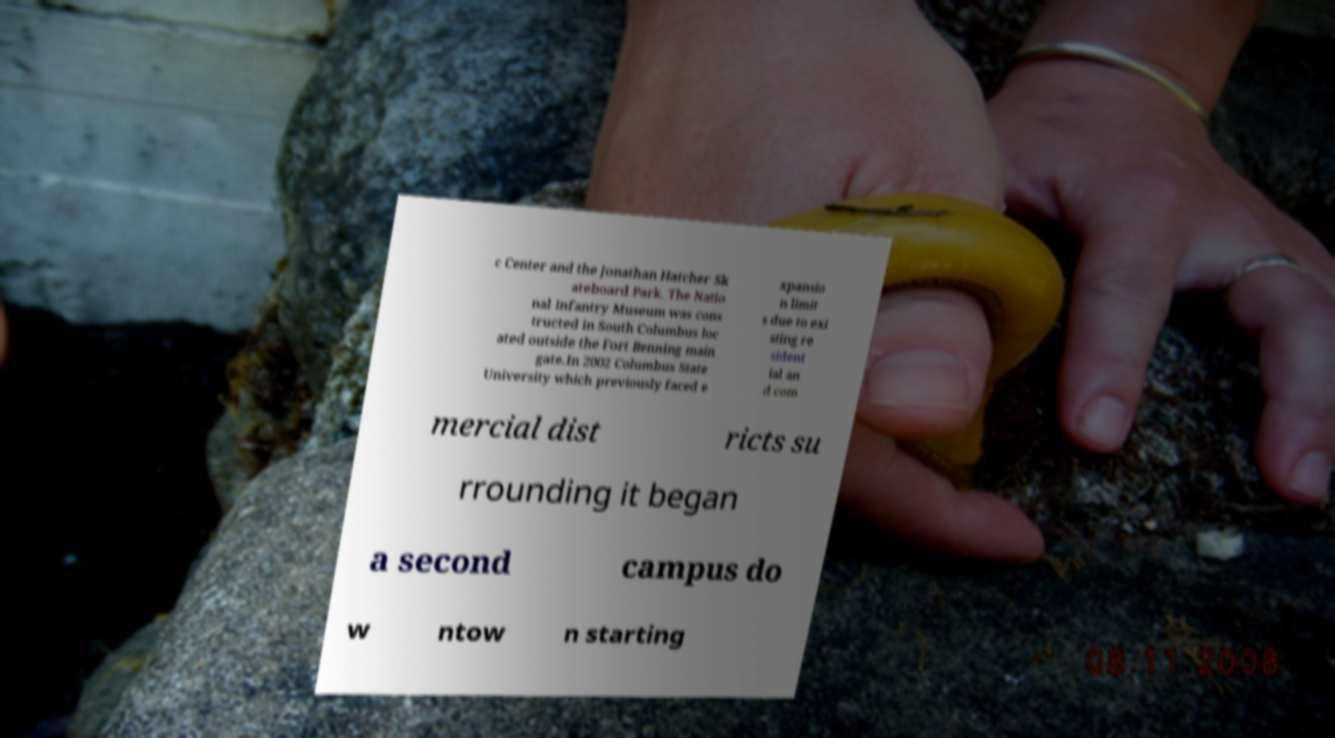Can you accurately transcribe the text from the provided image for me? c Center and the Jonathan Hatcher Sk ateboard Park. The Natio nal Infantry Museum was cons tructed in South Columbus loc ated outside the Fort Benning main gate.In 2002 Columbus State University which previously faced e xpansio n limit s due to exi sting re sident ial an d com mercial dist ricts su rrounding it began a second campus do w ntow n starting 